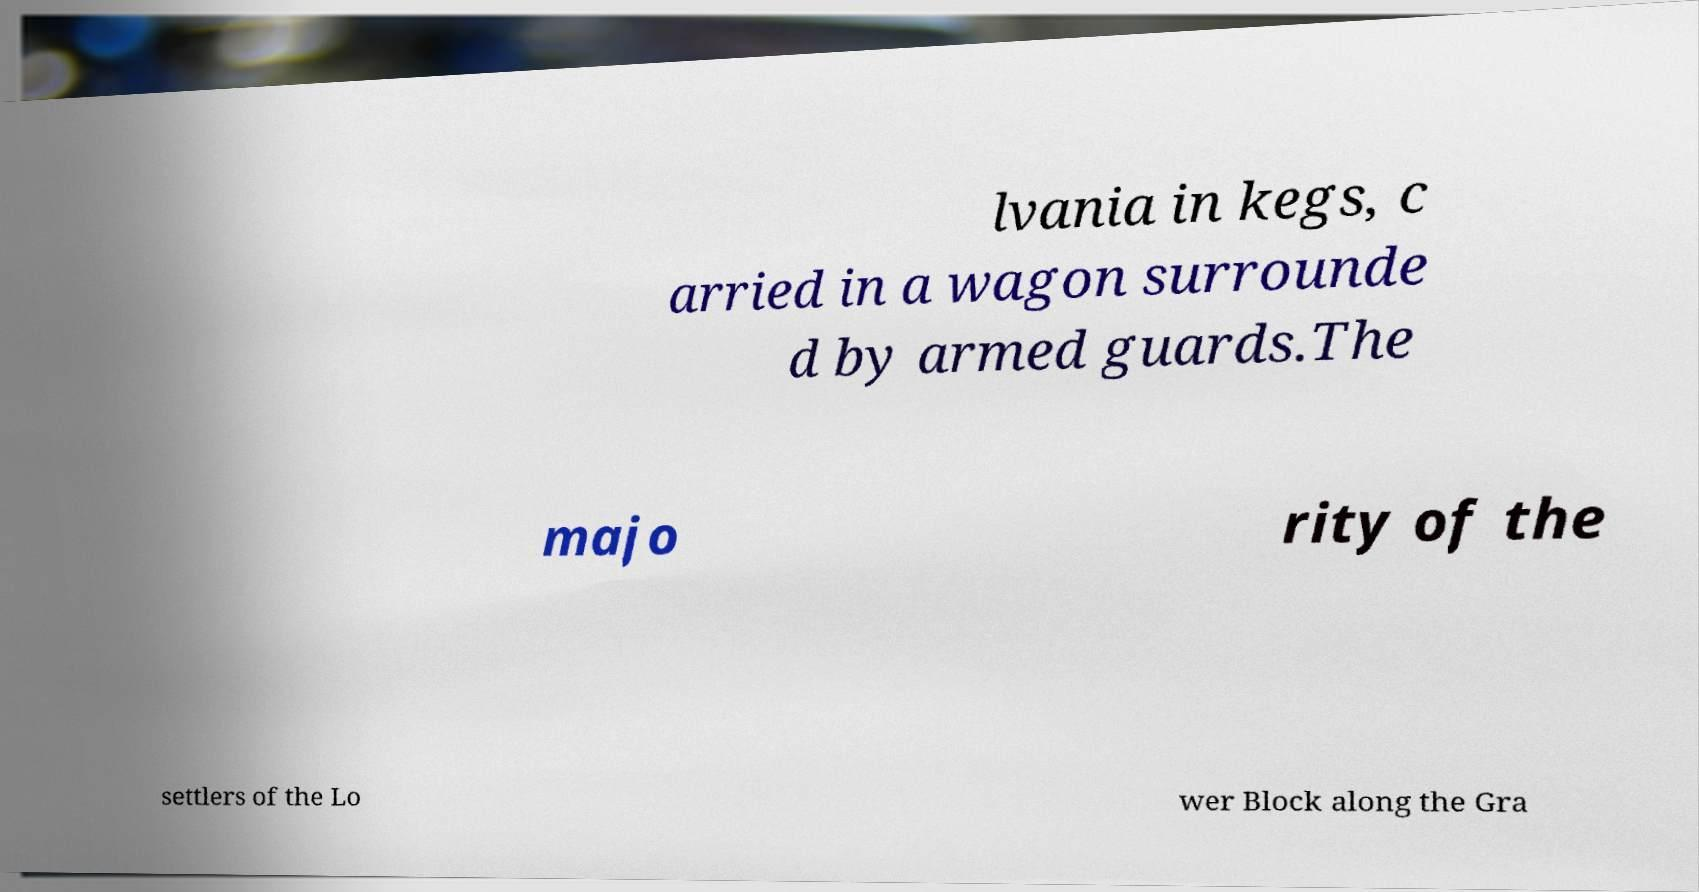What messages or text are displayed in this image? I need them in a readable, typed format. lvania in kegs, c arried in a wagon surrounde d by armed guards.The majo rity of the settlers of the Lo wer Block along the Gra 